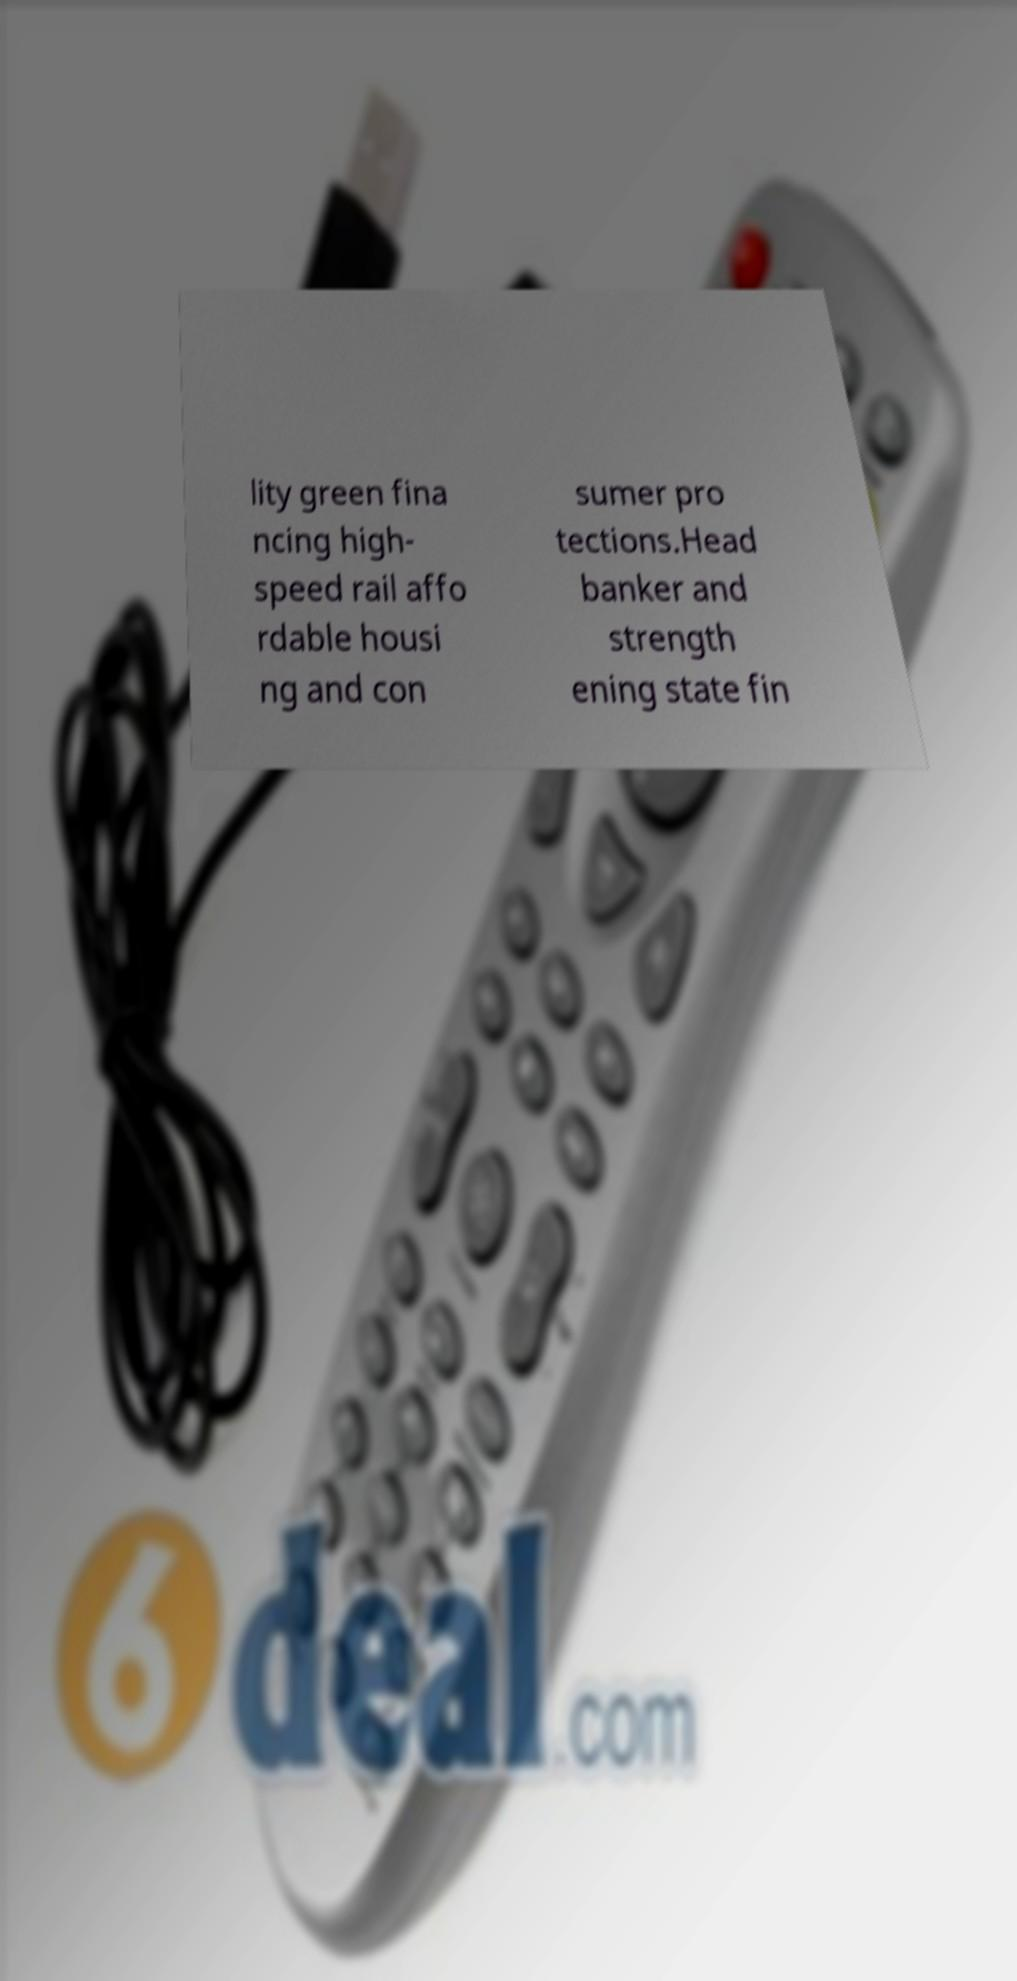Please read and relay the text visible in this image. What does it say? lity green fina ncing high- speed rail affo rdable housi ng and con sumer pro tections.Head banker and strength ening state fin 